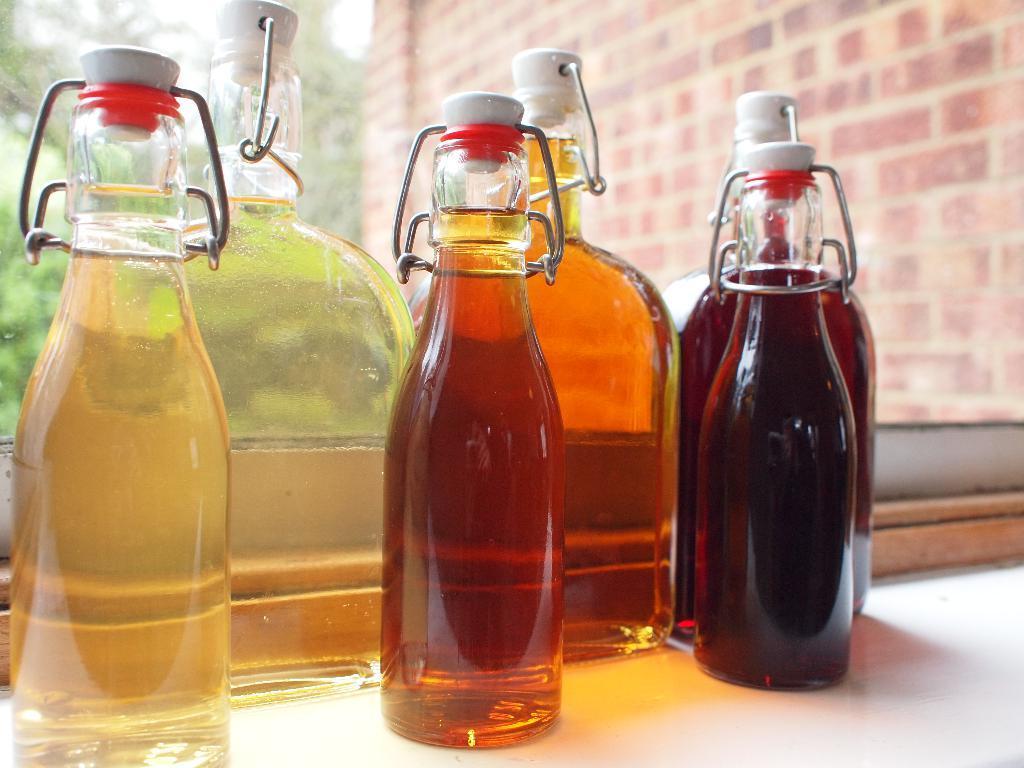In one or two sentences, can you explain what this image depicts? There are group of glass bottles which has some liquid in it is placed on a table. 